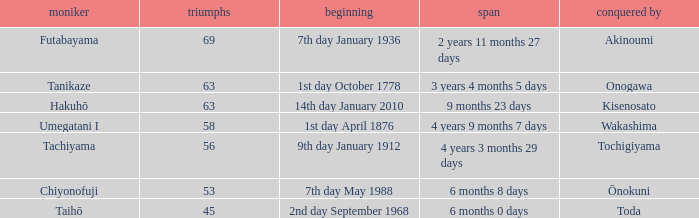How many wins were held before being defeated by toda? 1.0. 